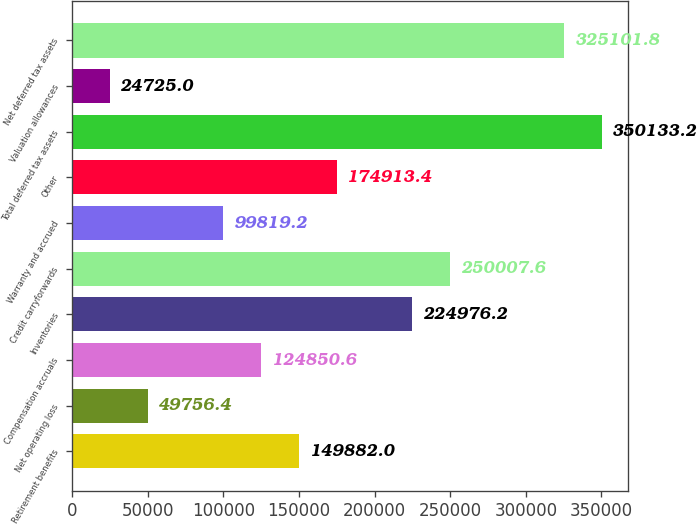Convert chart to OTSL. <chart><loc_0><loc_0><loc_500><loc_500><bar_chart><fcel>Retirement benefits<fcel>Net operating loss<fcel>Compensation accruals<fcel>Inventories<fcel>Credit carryforwards<fcel>Warranty and accrued<fcel>Other<fcel>Total deferred tax assets<fcel>Valuation allowances<fcel>Net deferred tax assets<nl><fcel>149882<fcel>49756.4<fcel>124851<fcel>224976<fcel>250008<fcel>99819.2<fcel>174913<fcel>350133<fcel>24725<fcel>325102<nl></chart> 